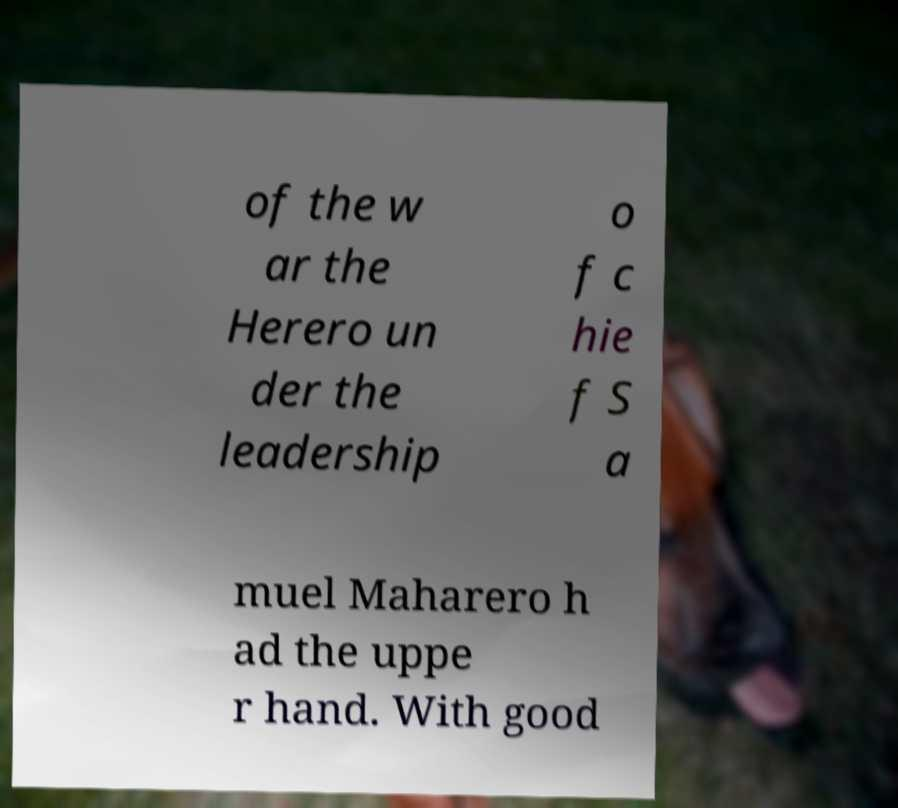For documentation purposes, I need the text within this image transcribed. Could you provide that? of the w ar the Herero un der the leadership o f c hie f S a muel Maharero h ad the uppe r hand. With good 